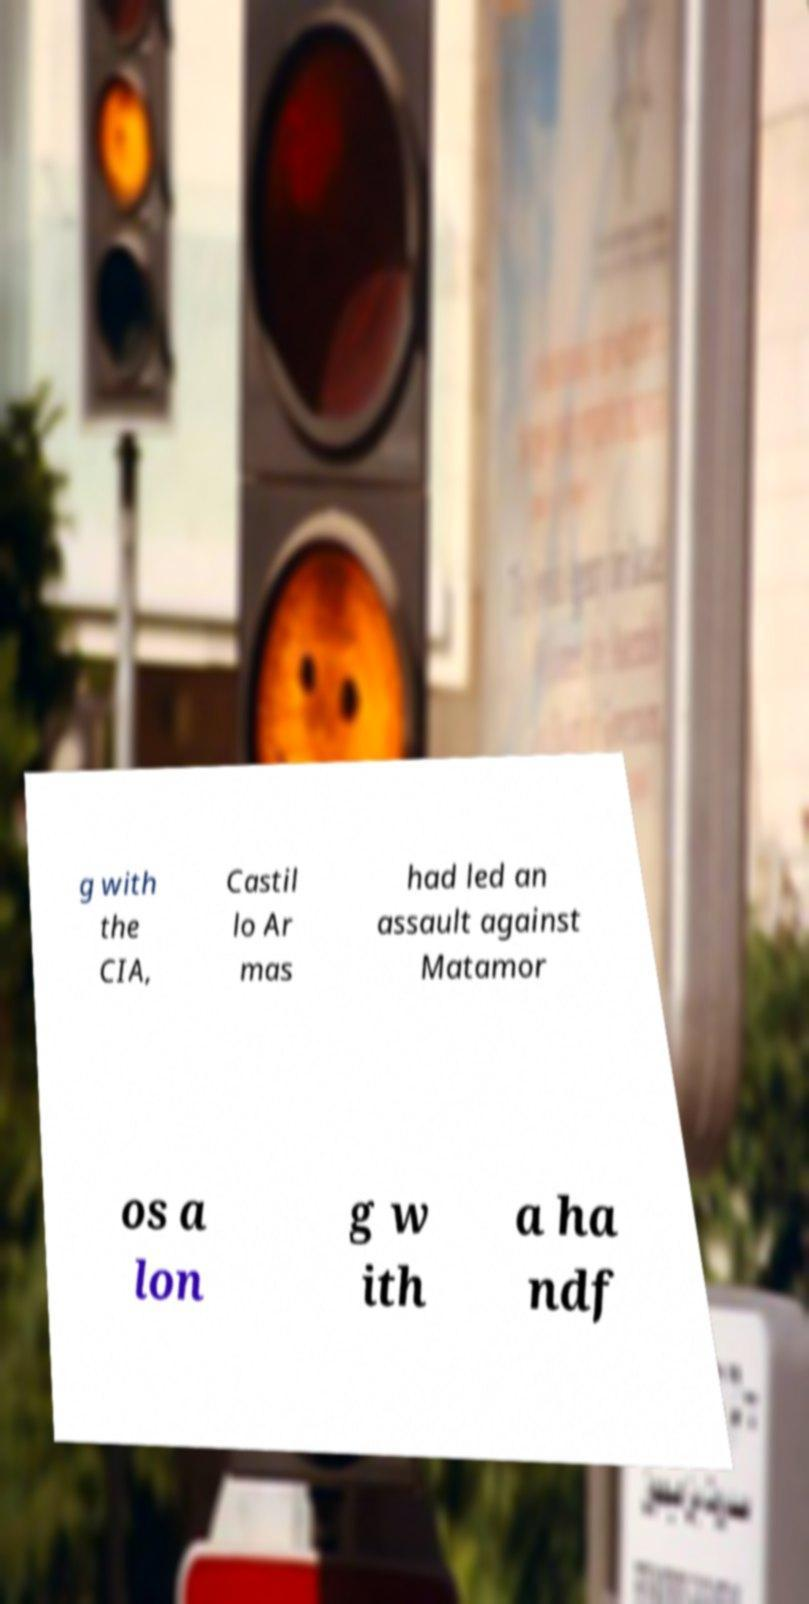Please read and relay the text visible in this image. What does it say? g with the CIA, Castil lo Ar mas had led an assault against Matamor os a lon g w ith a ha ndf 